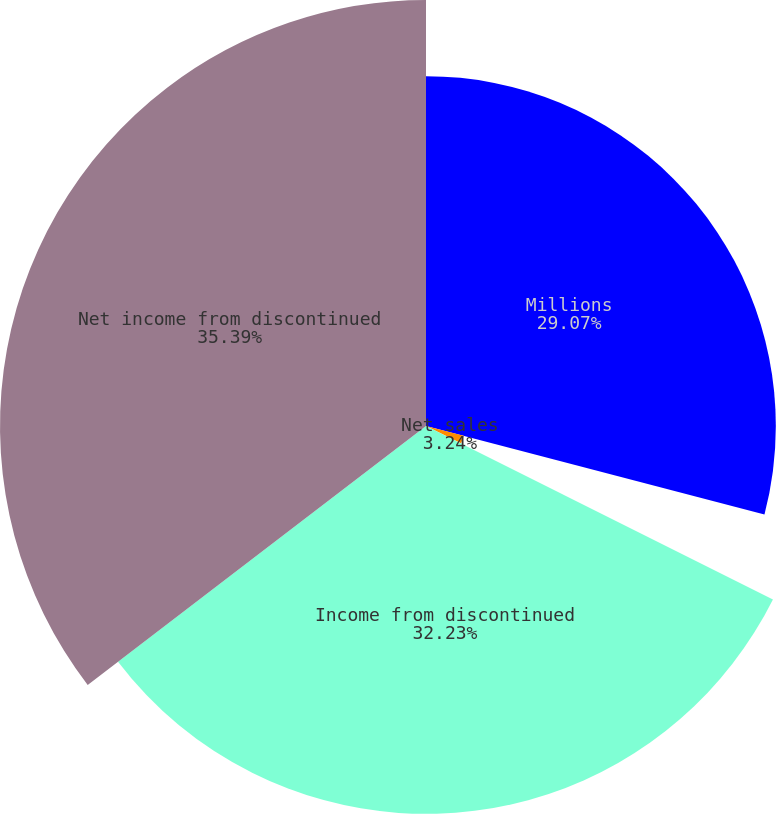<chart> <loc_0><loc_0><loc_500><loc_500><pie_chart><fcel>Millions<fcel>Net sales<fcel>Income tax expense<fcel>Income from discontinued<fcel>Net income from discontinued<nl><fcel>29.07%<fcel>3.24%<fcel>0.07%<fcel>32.23%<fcel>35.4%<nl></chart> 